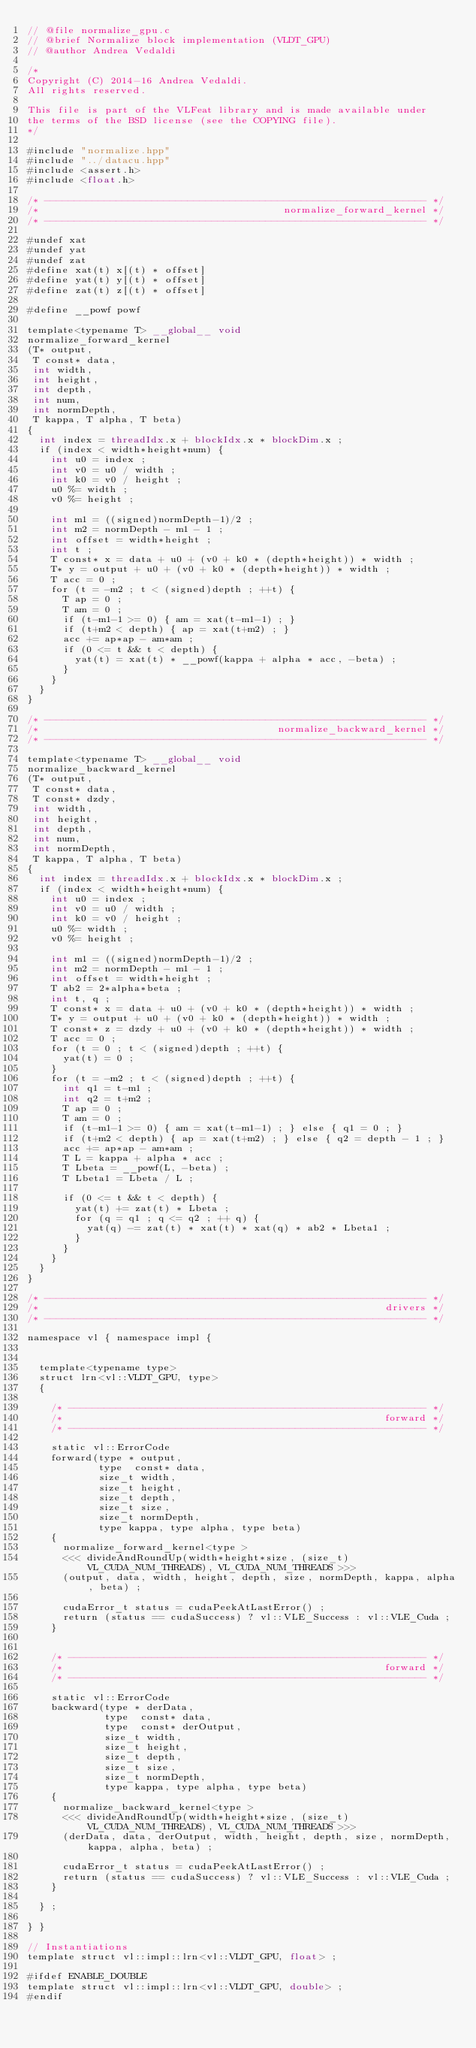Convert code to text. <code><loc_0><loc_0><loc_500><loc_500><_Cuda_>// @file normalize_gpu.c
// @brief Normalize block implementation (VLDT_GPU)
// @author Andrea Vedaldi

/*
Copyright (C) 2014-16 Andrea Vedaldi.
All rights reserved.

This file is part of the VLFeat library and is made available under
the terms of the BSD license (see the COPYING file).
*/

#include "normalize.hpp"
#include "../datacu.hpp"
#include <assert.h>
#include <float.h>

/* ---------------------------------------------------------------- */
/*                                         normalize_forward_kernel */
/* ---------------------------------------------------------------- */

#undef xat
#undef yat
#undef zat
#define xat(t) x[(t) * offset]
#define yat(t) y[(t) * offset]
#define zat(t) z[(t) * offset]

#define __powf powf

template<typename T> __global__ void
normalize_forward_kernel
(T* output,
 T const* data,
 int width,
 int height,
 int depth,
 int num,
 int normDepth,
 T kappa, T alpha, T beta)
{
  int index = threadIdx.x + blockIdx.x * blockDim.x ;
  if (index < width*height*num) {
    int u0 = index ;
    int v0 = u0 / width ;
    int k0 = v0 / height ;
    u0 %= width ;
    v0 %= height ;

    int m1 = ((signed)normDepth-1)/2 ;
    int m2 = normDepth - m1 - 1 ;
    int offset = width*height ;
    int t ;
    T const* x = data + u0 + (v0 + k0 * (depth*height)) * width ;
    T* y = output + u0 + (v0 + k0 * (depth*height)) * width ;
    T acc = 0 ;
    for (t = -m2 ; t < (signed)depth ; ++t) {
      T ap = 0 ;
      T am = 0 ;
      if (t-m1-1 >= 0) { am = xat(t-m1-1) ; }
      if (t+m2 < depth) { ap = xat(t+m2) ; }
      acc += ap*ap - am*am ;
      if (0 <= t && t < depth) {
        yat(t) = xat(t) * __powf(kappa + alpha * acc, -beta) ;
      }
    }
  }
}

/* ---------------------------------------------------------------- */
/*                                        normalize_backward_kernel */
/* ---------------------------------------------------------------- */

template<typename T> __global__ void
normalize_backward_kernel
(T* output,
 T const* data,
 T const* dzdy,
 int width,
 int height,
 int depth,
 int num,
 int normDepth,
 T kappa, T alpha, T beta)
{
  int index = threadIdx.x + blockIdx.x * blockDim.x ;
  if (index < width*height*num) {
    int u0 = index ;
    int v0 = u0 / width ;
    int k0 = v0 / height ;
    u0 %= width ;
    v0 %= height ;

    int m1 = ((signed)normDepth-1)/2 ;
    int m2 = normDepth - m1 - 1 ;
    int offset = width*height ;
    T ab2 = 2*alpha*beta ;
    int t, q ;
    T const* x = data + u0 + (v0 + k0 * (depth*height)) * width ;
    T* y = output + u0 + (v0 + k0 * (depth*height)) * width ;
    T const* z = dzdy + u0 + (v0 + k0 * (depth*height)) * width ;
    T acc = 0 ;
    for (t = 0 ; t < (signed)depth ; ++t) {
      yat(t) = 0 ;
    }
    for (t = -m2 ; t < (signed)depth ; ++t) {
      int q1 = t-m1 ;
      int q2 = t+m2 ;
      T ap = 0 ;
      T am = 0 ;
      if (t-m1-1 >= 0) { am = xat(t-m1-1) ; } else { q1 = 0 ; }
      if (t+m2 < depth) { ap = xat(t+m2) ; } else { q2 = depth - 1 ; }
      acc += ap*ap - am*am ;
      T L = kappa + alpha * acc ;
      T Lbeta = __powf(L, -beta) ;
      T Lbeta1 = Lbeta / L ;

      if (0 <= t && t < depth) {
        yat(t) += zat(t) * Lbeta ;
        for (q = q1 ; q <= q2 ; ++ q) {
          yat(q) -= zat(t) * xat(t) * xat(q) * ab2 * Lbeta1 ;
        }
      }
    }
  }
}

/* ---------------------------------------------------------------- */
/*                                                          drivers */
/* ---------------------------------------------------------------- */

namespace vl { namespace impl {


  template<typename type>
  struct lrn<vl::VLDT_GPU, type>
  {

    /* ------------------------------------------------------------ */
    /*                                                      forward */
    /* ------------------------------------------------------------ */

    static vl::ErrorCode
    forward(type * output,
            type  const* data,
            size_t width,
            size_t height,
            size_t depth,
            size_t size,
            size_t normDepth,
            type kappa, type alpha, type beta)
    {
      normalize_forward_kernel<type >
      <<< divideAndRoundUp(width*height*size, (size_t)VL_CUDA_NUM_THREADS), VL_CUDA_NUM_THREADS >>>
      (output, data, width, height, depth, size, normDepth, kappa, alpha, beta) ;

      cudaError_t status = cudaPeekAtLastError() ;
      return (status == cudaSuccess) ? vl::VLE_Success : vl::VLE_Cuda ;
    }


    /* ------------------------------------------------------------ */
    /*                                                      forward */
    /* ------------------------------------------------------------ */

    static vl::ErrorCode
    backward(type * derData,
             type  const* data,
             type  const* derOutput,
             size_t width,
             size_t height,
             size_t depth,
             size_t size,
             size_t normDepth,
             type kappa, type alpha, type beta)
    {
      normalize_backward_kernel<type >
      <<< divideAndRoundUp(width*height*size, (size_t)VL_CUDA_NUM_THREADS), VL_CUDA_NUM_THREADS >>>
      (derData, data, derOutput, width, height, depth, size, normDepth, kappa, alpha, beta) ;

      cudaError_t status = cudaPeekAtLastError() ;
      return (status == cudaSuccess) ? vl::VLE_Success : vl::VLE_Cuda ;
    }

  } ;

} }

// Instantiations
template struct vl::impl::lrn<vl::VLDT_GPU, float> ;

#ifdef ENABLE_DOUBLE
template struct vl::impl::lrn<vl::VLDT_GPU, double> ;
#endif



</code> 